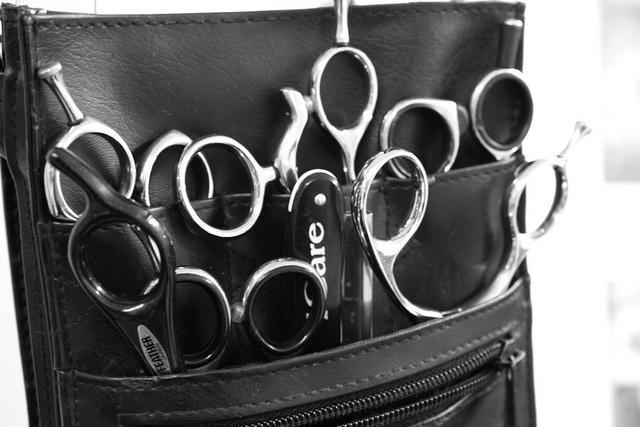How many circles are there?
Give a very brief answer. 11. How many scissors are visible?
Give a very brief answer. 5. How many people are holding frisbees?
Give a very brief answer. 0. 